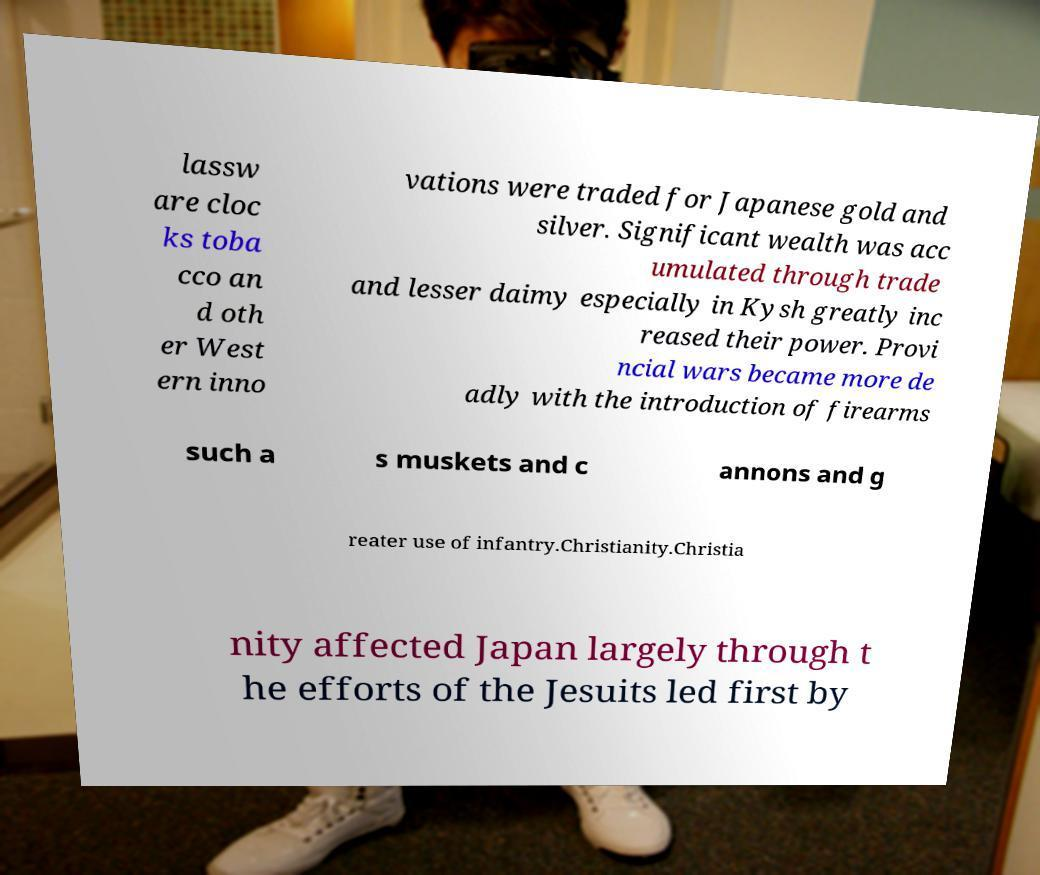What messages or text are displayed in this image? I need them in a readable, typed format. lassw are cloc ks toba cco an d oth er West ern inno vations were traded for Japanese gold and silver. Significant wealth was acc umulated through trade and lesser daimy especially in Kysh greatly inc reased their power. Provi ncial wars became more de adly with the introduction of firearms such a s muskets and c annons and g reater use of infantry.Christianity.Christia nity affected Japan largely through t he efforts of the Jesuits led first by 